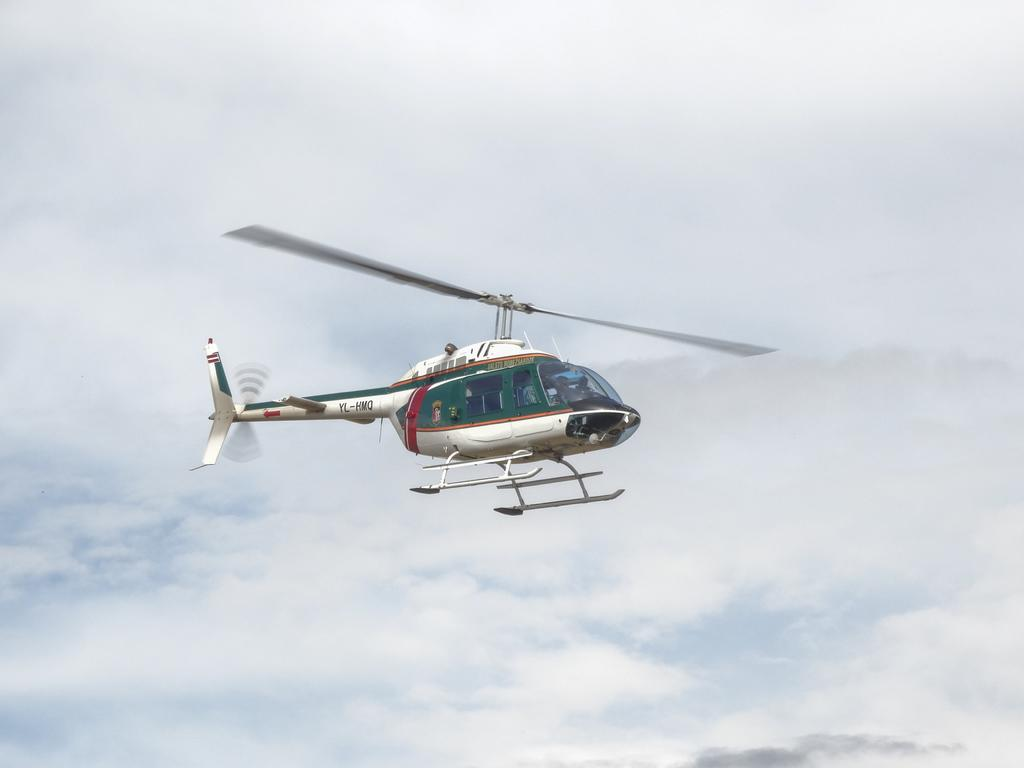What is the main subject of the image? The main subject of the image is a helicopter. Can you describe the position of the helicopter in the image? The helicopter is in the air in the image. What can be seen in the background of the image? The sky is visible in the background of the image. What type of grain is being harvested by the donkey in the image? There is no donkey or grain present in the image; it features a helicopter in the air. How many cards are being held by the person in the image? There is no person or cards present in the image; it features a helicopter in the air. 